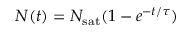<formula> <loc_0><loc_0><loc_500><loc_500>N ( t ) = { N _ { s a t } } ( 1 - e ^ { - t / \tau } )</formula> 